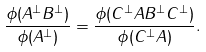Convert formula to latex. <formula><loc_0><loc_0><loc_500><loc_500>\frac { \phi ( A ^ { \perp } B ^ { \perp } ) } { \phi ( A ^ { \perp } ) } = \frac { \phi ( C ^ { \perp } A B ^ { \perp } C ^ { \perp } ) } { \phi ( C ^ { \perp } A ) } .</formula> 